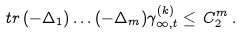<formula> <loc_0><loc_0><loc_500><loc_500>\ t r \, ( - \Delta _ { 1 } ) \dots ( - \Delta _ { m } ) \gamma ^ { ( k ) } _ { \infty , t } \leq \, C _ { 2 } ^ { m } \, .</formula> 